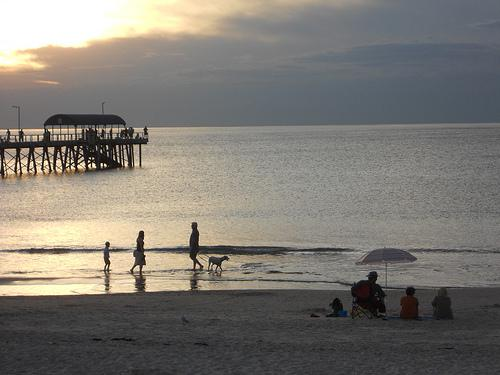Question: when was this photo taken?
Choices:
A. Sunset.
B. Halloween.
C. Easter.
D. Fathers day.
Answer with the letter. Answer: A Question: what is walking in the water on a leash?
Choices:
A. Dog.
B. Cat.
C. Horse.
D. A poodle.
Answer with the letter. Answer: A Question: what are people sitting underneath?
Choices:
A. Tent.
B. Umbrella.
C. Awning.
D. Scaffolding.
Answer with the letter. Answer: B Question: where was this picture taken?
Choices:
A. The beach.
B. Hotel.
C. Utah.
D. Paris.
Answer with the letter. Answer: A Question: what color is the sand?
Choices:
A. Brown.
B. Tan.
C. Grey.
D. Yellow.
Answer with the letter. Answer: C Question: what structure is in the middle of the water?
Choices:
A. Boat.
B. Paddle.
C. Ship.
D. Pier.
Answer with the letter. Answer: D Question: how many people are sitting by the umbrella?
Choices:
A. Four.
B. Three.
C. Five.
D. Six.
Answer with the letter. Answer: B 